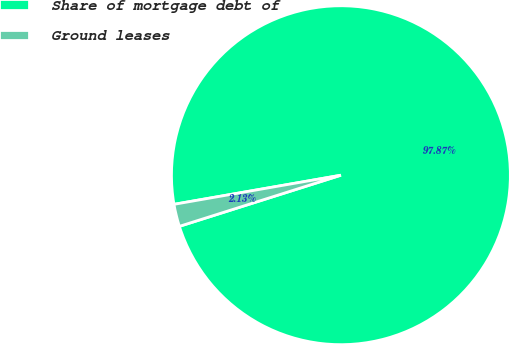<chart> <loc_0><loc_0><loc_500><loc_500><pie_chart><fcel>Share of mortgage debt of<fcel>Ground leases<nl><fcel>97.87%<fcel>2.13%<nl></chart> 